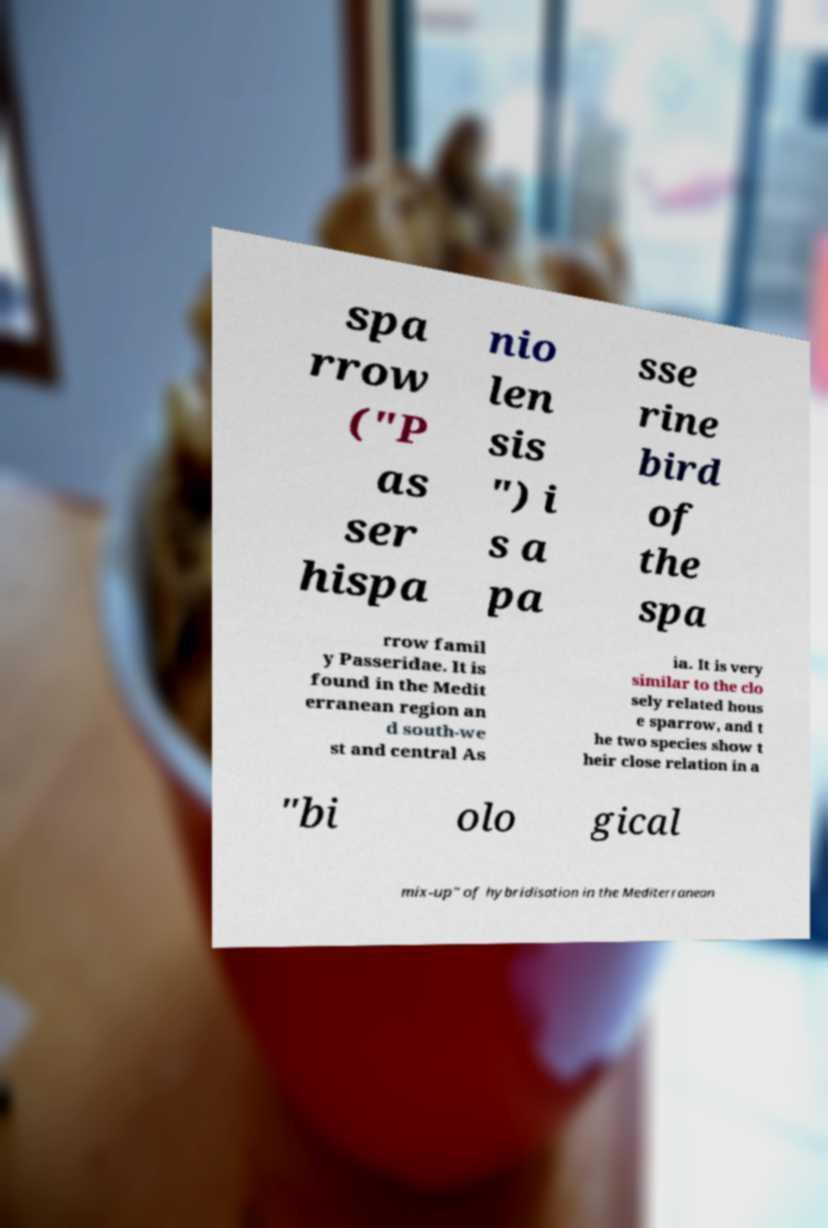Please identify and transcribe the text found in this image. spa rrow ("P as ser hispa nio len sis ") i s a pa sse rine bird of the spa rrow famil y Passeridae. It is found in the Medit erranean region an d south-we st and central As ia. It is very similar to the clo sely related hous e sparrow, and t he two species show t heir close relation in a "bi olo gical mix-up" of hybridisation in the Mediterranean 